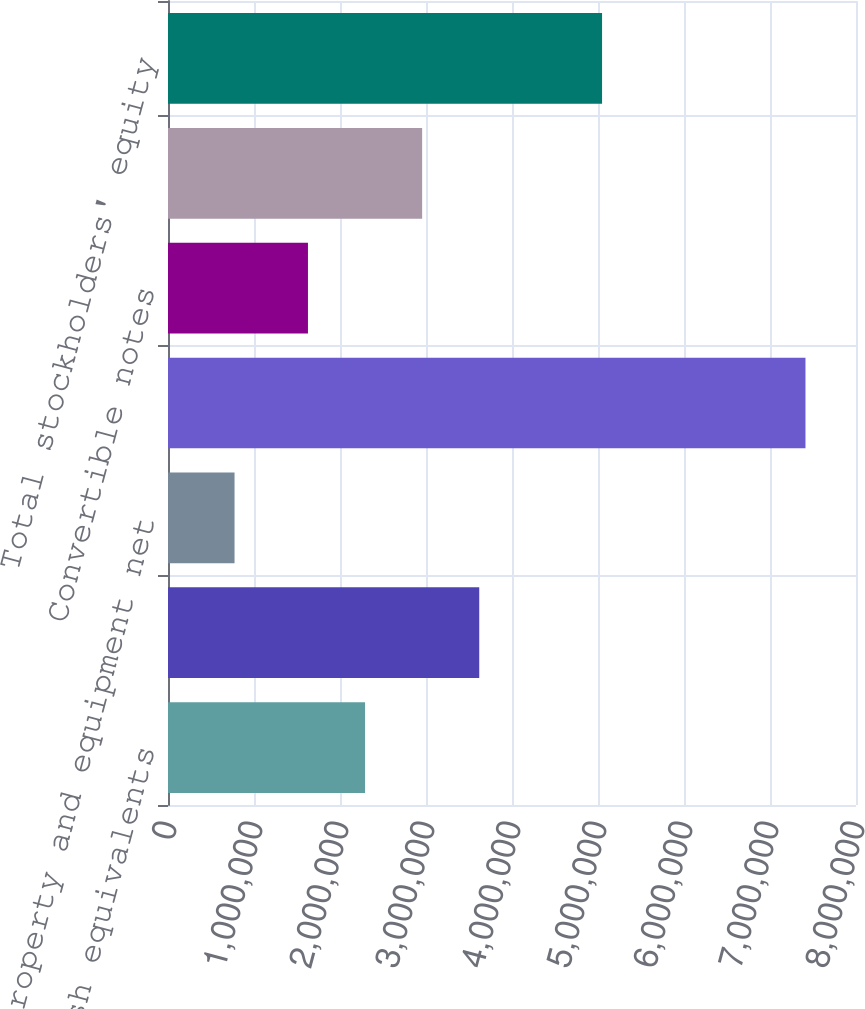<chart> <loc_0><loc_0><loc_500><loc_500><bar_chart><fcel>Cash and cash equivalents<fcel>Short-term investments<fcel>Property and equipment net<fcel>Total assets<fcel>Convertible notes<fcel>Total liabilities<fcel>Total stockholders' equity<nl><fcel>2.29134e+06<fcel>3.61909e+06<fcel>773715<fcel>7.41248e+06<fcel>1.62746e+06<fcel>2.95521e+06<fcel>5.04722e+06<nl></chart> 